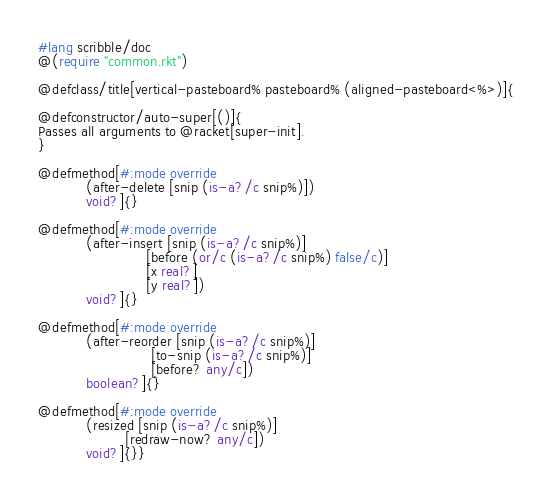<code> <loc_0><loc_0><loc_500><loc_500><_Racket_>#lang scribble/doc
@(require "common.rkt")

@defclass/title[vertical-pasteboard% pasteboard% (aligned-pasteboard<%>)]{

@defconstructor/auto-super[()]{
Passes all arguments to @racket[super-init].
}

@defmethod[#:mode override 
           (after-delete [snip (is-a?/c snip%)])
           void?]{}

@defmethod[#:mode override 
           (after-insert [snip (is-a?/c snip%)]
                         [before (or/c (is-a?/c snip%) false/c)]
                         [x real?]
                         [y real?])
           void?]{}

@defmethod[#:mode override 
           (after-reorder [snip (is-a?/c snip%)]
                          [to-snip (is-a?/c snip%)]
                          [before? any/c])
           boolean?]{}

@defmethod[#:mode override 
           (resized [snip (is-a?/c snip%)]
                    [redraw-now? any/c])
           void?]{}}
</code> 